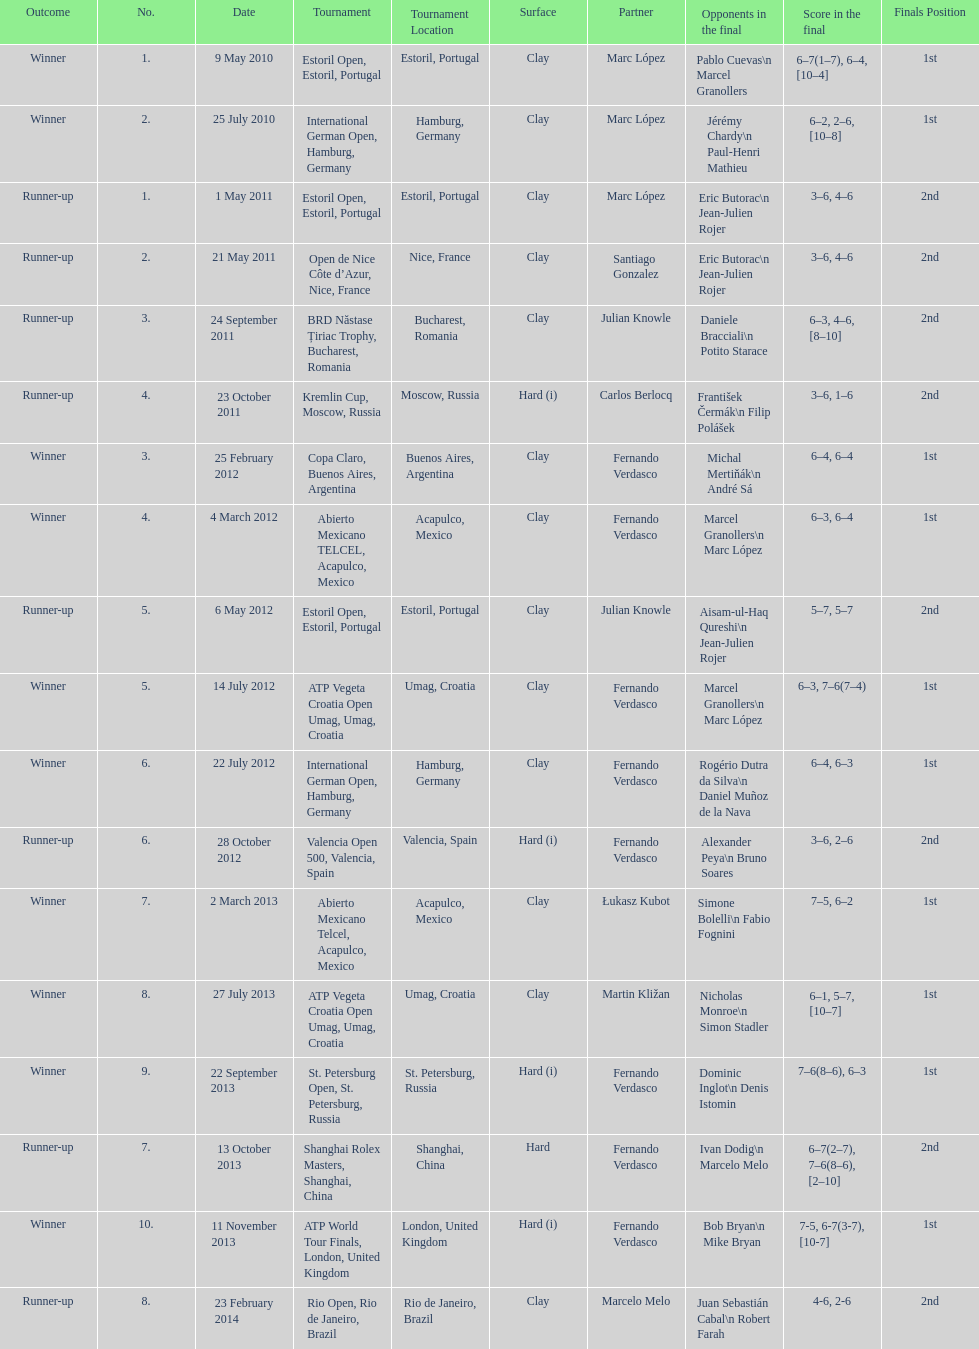What is the total number of runner-ups listed on the chart? 8. 